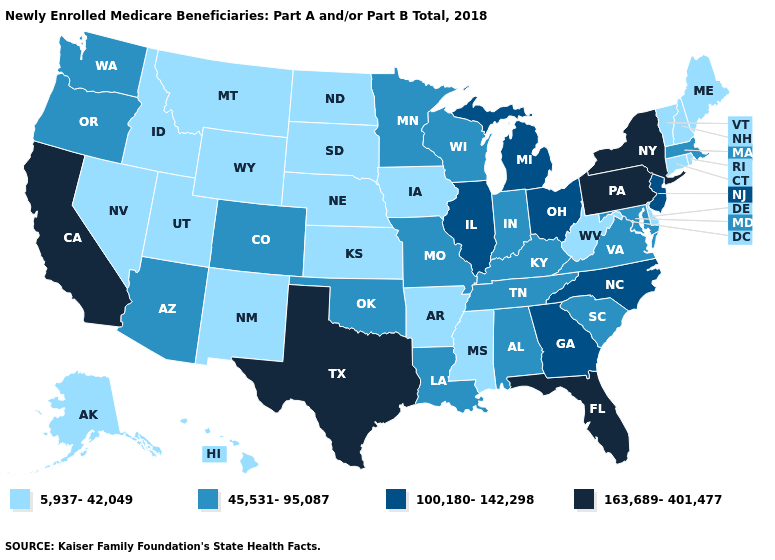Does Mississippi have the lowest value in the USA?
Keep it brief. Yes. Is the legend a continuous bar?
Short answer required. No. Does California have the highest value in the USA?
Concise answer only. Yes. Which states have the lowest value in the South?
Keep it brief. Arkansas, Delaware, Mississippi, West Virginia. Does Minnesota have a lower value than Kentucky?
Keep it brief. No. Does Montana have the highest value in the USA?
Answer briefly. No. Does West Virginia have the highest value in the USA?
Quick response, please. No. Which states have the highest value in the USA?
Give a very brief answer. California, Florida, New York, Pennsylvania, Texas. Which states hav the highest value in the Northeast?
Be succinct. New York, Pennsylvania. How many symbols are there in the legend?
Give a very brief answer. 4. What is the highest value in states that border Oklahoma?
Answer briefly. 163,689-401,477. Does the map have missing data?
Quick response, please. No. Does New York have the highest value in the Northeast?
Answer briefly. Yes. What is the value of Massachusetts?
Be succinct. 45,531-95,087. Which states have the highest value in the USA?
Keep it brief. California, Florida, New York, Pennsylvania, Texas. 